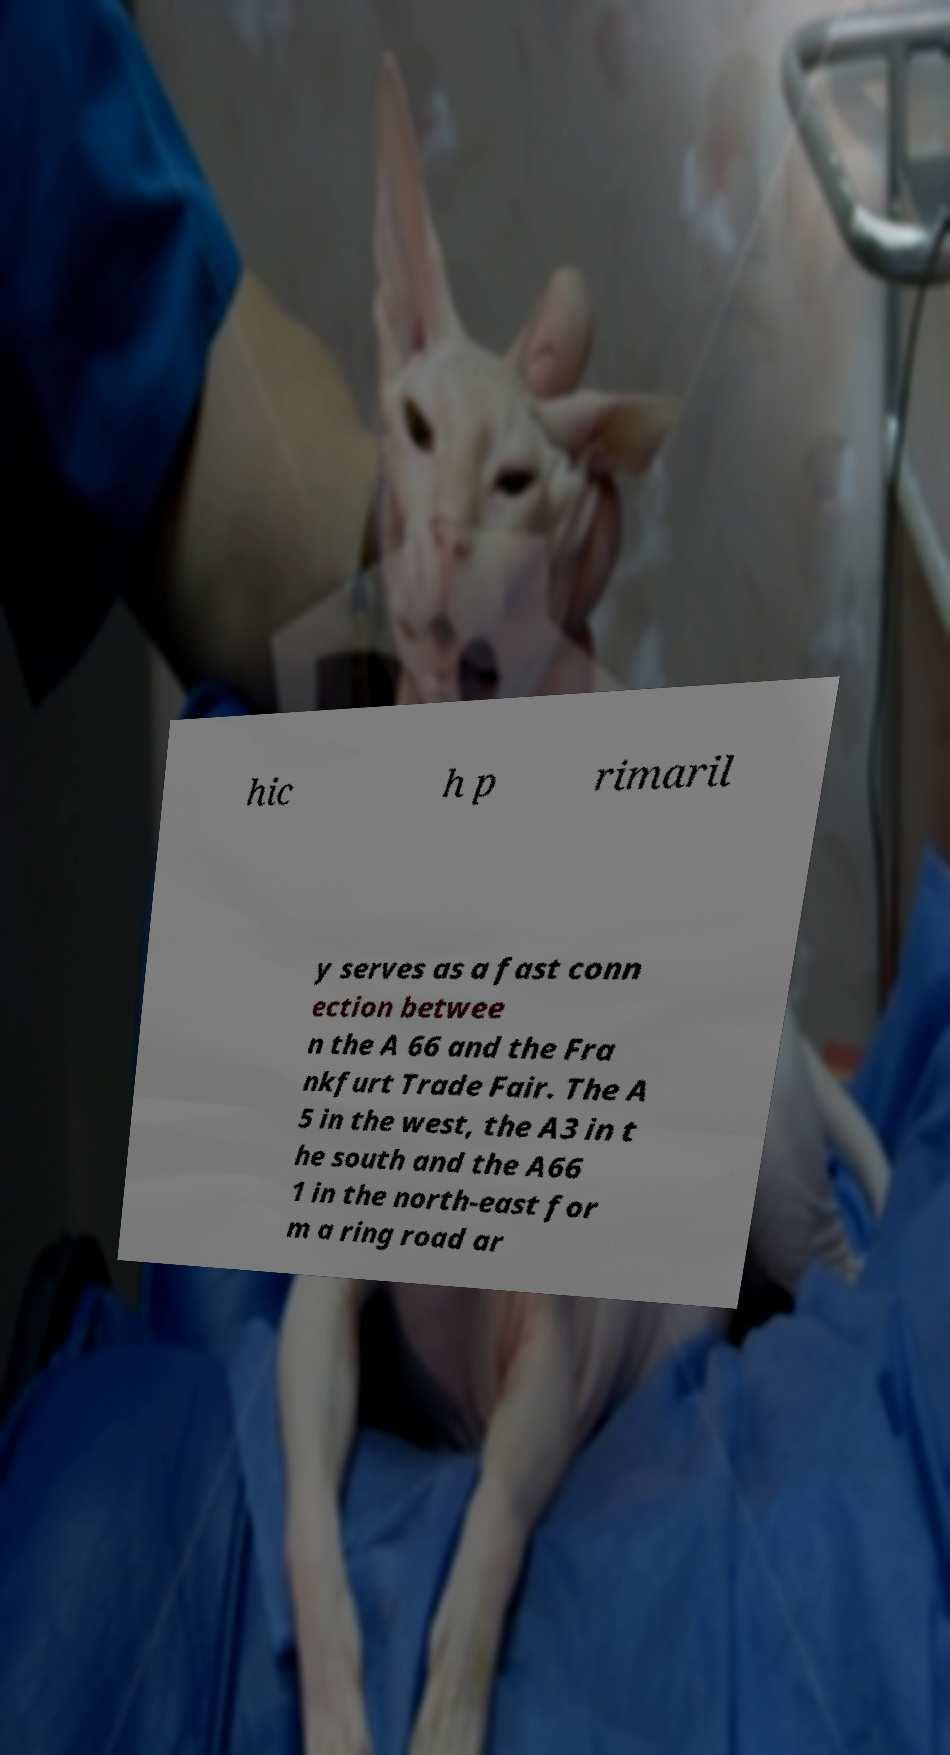Could you extract and type out the text from this image? hic h p rimaril y serves as a fast conn ection betwee n the A 66 and the Fra nkfurt Trade Fair. The A 5 in the west, the A3 in t he south and the A66 1 in the north-east for m a ring road ar 